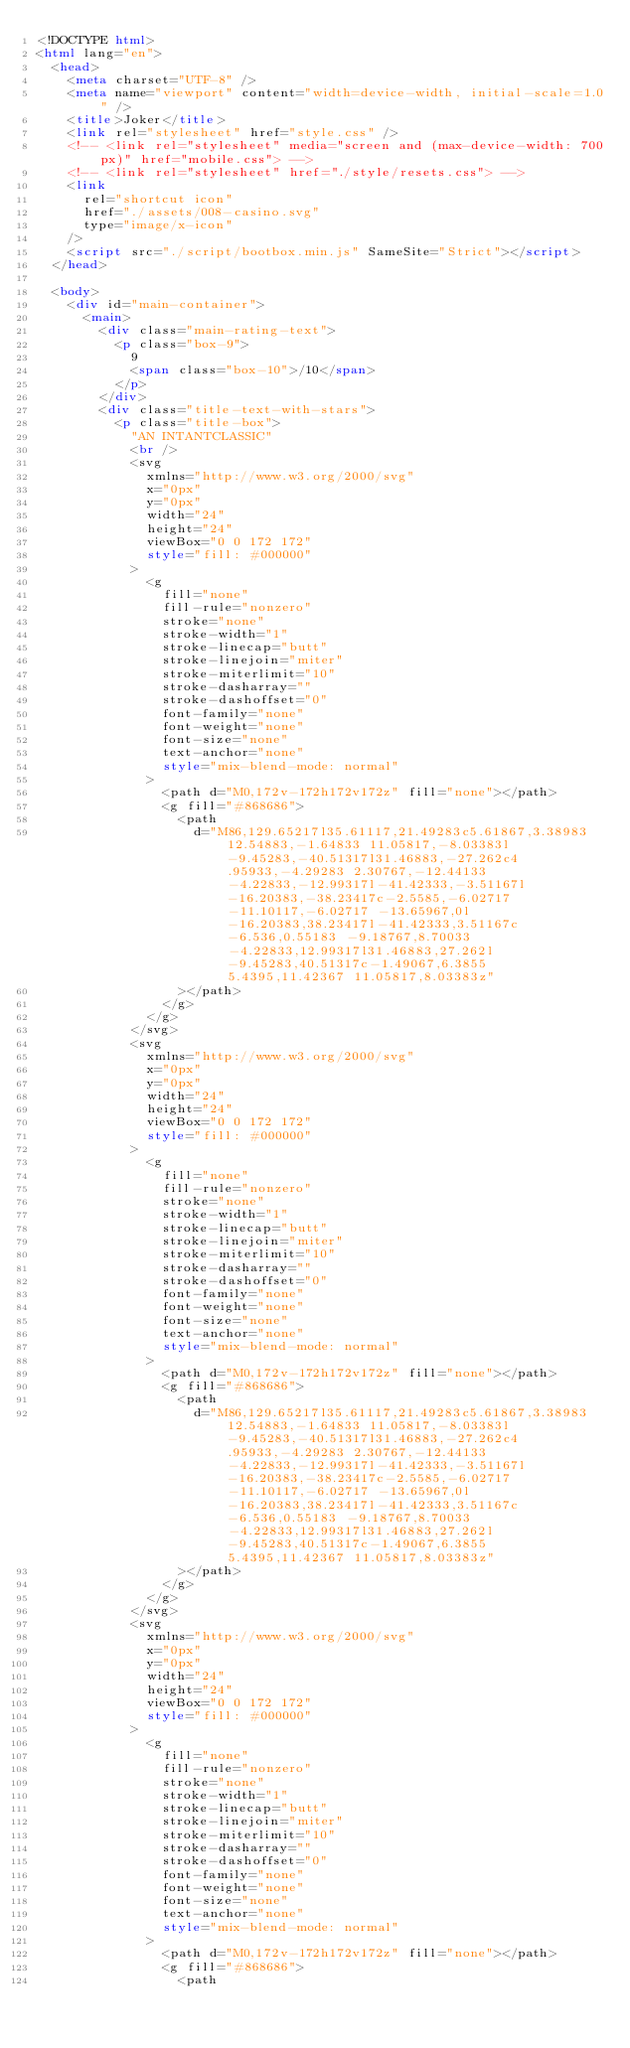<code> <loc_0><loc_0><loc_500><loc_500><_HTML_><!DOCTYPE html>
<html lang="en">
  <head>
    <meta charset="UTF-8" />
    <meta name="viewport" content="width=device-width, initial-scale=1.0" />
    <title>Joker</title>
    <link rel="stylesheet" href="style.css" />
    <!-- <link rel="stylesheet" media="screen and (max-device-width: 700px)" href="mobile.css"> -->
    <!-- <link rel="stylesheet" href="./style/resets.css"> -->
    <link
      rel="shortcut icon"
      href="./assets/008-casino.svg"
      type="image/x-icon"
    />
    <script src="./script/bootbox.min.js" SameSite="Strict"></script>
  </head>

  <body>
    <div id="main-container">
      <main>
        <div class="main-rating-text">
          <p class="box-9">
            9
            <span class="box-10">/10</span>
          </p>
        </div>
        <div class="title-text-with-stars">
          <p class="title-box">
            "AN INTANTCLASSIC"
            <br />
            <svg
              xmlns="http://www.w3.org/2000/svg"
              x="0px"
              y="0px"
              width="24"
              height="24"
              viewBox="0 0 172 172"
              style="fill: #000000"
            >
              <g
                fill="none"
                fill-rule="nonzero"
                stroke="none"
                stroke-width="1"
                stroke-linecap="butt"
                stroke-linejoin="miter"
                stroke-miterlimit="10"
                stroke-dasharray=""
                stroke-dashoffset="0"
                font-family="none"
                font-weight="none"
                font-size="none"
                text-anchor="none"
                style="mix-blend-mode: normal"
              >
                <path d="M0,172v-172h172v172z" fill="none"></path>
                <g fill="#868686">
                  <path
                    d="M86,129.65217l35.61117,21.49283c5.61867,3.38983 12.54883,-1.64833 11.05817,-8.03383l-9.45283,-40.51317l31.46883,-27.262c4.95933,-4.29283 2.30767,-12.44133 -4.22833,-12.99317l-41.42333,-3.51167l-16.20383,-38.23417c-2.5585,-6.02717 -11.10117,-6.02717 -13.65967,0l-16.20383,38.23417l-41.42333,3.51167c-6.536,0.55183 -9.18767,8.70033 -4.22833,12.99317l31.46883,27.262l-9.45283,40.51317c-1.49067,6.3855 5.4395,11.42367 11.05817,8.03383z"
                  ></path>
                </g>
              </g>
            </svg>
            <svg
              xmlns="http://www.w3.org/2000/svg"
              x="0px"
              y="0px"
              width="24"
              height="24"
              viewBox="0 0 172 172"
              style="fill: #000000"
            >
              <g
                fill="none"
                fill-rule="nonzero"
                stroke="none"
                stroke-width="1"
                stroke-linecap="butt"
                stroke-linejoin="miter"
                stroke-miterlimit="10"
                stroke-dasharray=""
                stroke-dashoffset="0"
                font-family="none"
                font-weight="none"
                font-size="none"
                text-anchor="none"
                style="mix-blend-mode: normal"
              >
                <path d="M0,172v-172h172v172z" fill="none"></path>
                <g fill="#868686">
                  <path
                    d="M86,129.65217l35.61117,21.49283c5.61867,3.38983 12.54883,-1.64833 11.05817,-8.03383l-9.45283,-40.51317l31.46883,-27.262c4.95933,-4.29283 2.30767,-12.44133 -4.22833,-12.99317l-41.42333,-3.51167l-16.20383,-38.23417c-2.5585,-6.02717 -11.10117,-6.02717 -13.65967,0l-16.20383,38.23417l-41.42333,3.51167c-6.536,0.55183 -9.18767,8.70033 -4.22833,12.99317l31.46883,27.262l-9.45283,40.51317c-1.49067,6.3855 5.4395,11.42367 11.05817,8.03383z"
                  ></path>
                </g>
              </g>
            </svg>
            <svg
              xmlns="http://www.w3.org/2000/svg"
              x="0px"
              y="0px"
              width="24"
              height="24"
              viewBox="0 0 172 172"
              style="fill: #000000"
            >
              <g
                fill="none"
                fill-rule="nonzero"
                stroke="none"
                stroke-width="1"
                stroke-linecap="butt"
                stroke-linejoin="miter"
                stroke-miterlimit="10"
                stroke-dasharray=""
                stroke-dashoffset="0"
                font-family="none"
                font-weight="none"
                font-size="none"
                text-anchor="none"
                style="mix-blend-mode: normal"
              >
                <path d="M0,172v-172h172v172z" fill="none"></path>
                <g fill="#868686">
                  <path</code> 